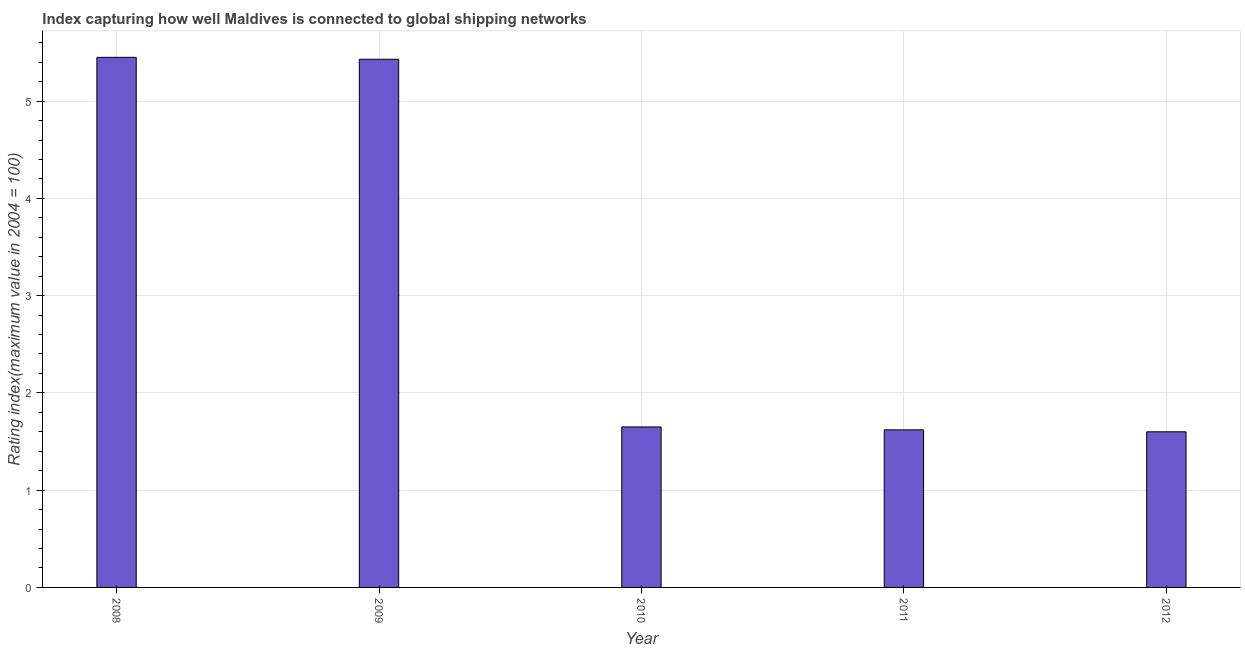Does the graph contain any zero values?
Offer a very short reply. No. Does the graph contain grids?
Give a very brief answer. Yes. What is the title of the graph?
Your answer should be very brief. Index capturing how well Maldives is connected to global shipping networks. What is the label or title of the Y-axis?
Your response must be concise. Rating index(maximum value in 2004 = 100). What is the liner shipping connectivity index in 2008?
Ensure brevity in your answer.  5.45. Across all years, what is the maximum liner shipping connectivity index?
Your response must be concise. 5.45. What is the sum of the liner shipping connectivity index?
Keep it short and to the point. 15.75. What is the difference between the liner shipping connectivity index in 2008 and 2011?
Keep it short and to the point. 3.83. What is the average liner shipping connectivity index per year?
Your answer should be compact. 3.15. What is the median liner shipping connectivity index?
Offer a terse response. 1.65. What is the difference between the highest and the second highest liner shipping connectivity index?
Ensure brevity in your answer.  0.02. Is the sum of the liner shipping connectivity index in 2008 and 2011 greater than the maximum liner shipping connectivity index across all years?
Your response must be concise. Yes. What is the difference between the highest and the lowest liner shipping connectivity index?
Offer a terse response. 3.85. Are the values on the major ticks of Y-axis written in scientific E-notation?
Ensure brevity in your answer.  No. What is the Rating index(maximum value in 2004 = 100) of 2008?
Make the answer very short. 5.45. What is the Rating index(maximum value in 2004 = 100) in 2009?
Your answer should be very brief. 5.43. What is the Rating index(maximum value in 2004 = 100) of 2010?
Make the answer very short. 1.65. What is the Rating index(maximum value in 2004 = 100) in 2011?
Ensure brevity in your answer.  1.62. What is the difference between the Rating index(maximum value in 2004 = 100) in 2008 and 2010?
Offer a very short reply. 3.8. What is the difference between the Rating index(maximum value in 2004 = 100) in 2008 and 2011?
Offer a terse response. 3.83. What is the difference between the Rating index(maximum value in 2004 = 100) in 2008 and 2012?
Give a very brief answer. 3.85. What is the difference between the Rating index(maximum value in 2004 = 100) in 2009 and 2010?
Your answer should be compact. 3.78. What is the difference between the Rating index(maximum value in 2004 = 100) in 2009 and 2011?
Make the answer very short. 3.81. What is the difference between the Rating index(maximum value in 2004 = 100) in 2009 and 2012?
Give a very brief answer. 3.83. What is the difference between the Rating index(maximum value in 2004 = 100) in 2010 and 2011?
Make the answer very short. 0.03. What is the difference between the Rating index(maximum value in 2004 = 100) in 2010 and 2012?
Make the answer very short. 0.05. What is the ratio of the Rating index(maximum value in 2004 = 100) in 2008 to that in 2009?
Keep it short and to the point. 1. What is the ratio of the Rating index(maximum value in 2004 = 100) in 2008 to that in 2010?
Your response must be concise. 3.3. What is the ratio of the Rating index(maximum value in 2004 = 100) in 2008 to that in 2011?
Your answer should be compact. 3.36. What is the ratio of the Rating index(maximum value in 2004 = 100) in 2008 to that in 2012?
Offer a very short reply. 3.41. What is the ratio of the Rating index(maximum value in 2004 = 100) in 2009 to that in 2010?
Provide a succinct answer. 3.29. What is the ratio of the Rating index(maximum value in 2004 = 100) in 2009 to that in 2011?
Offer a terse response. 3.35. What is the ratio of the Rating index(maximum value in 2004 = 100) in 2009 to that in 2012?
Your response must be concise. 3.39. What is the ratio of the Rating index(maximum value in 2004 = 100) in 2010 to that in 2012?
Your answer should be very brief. 1.03. 